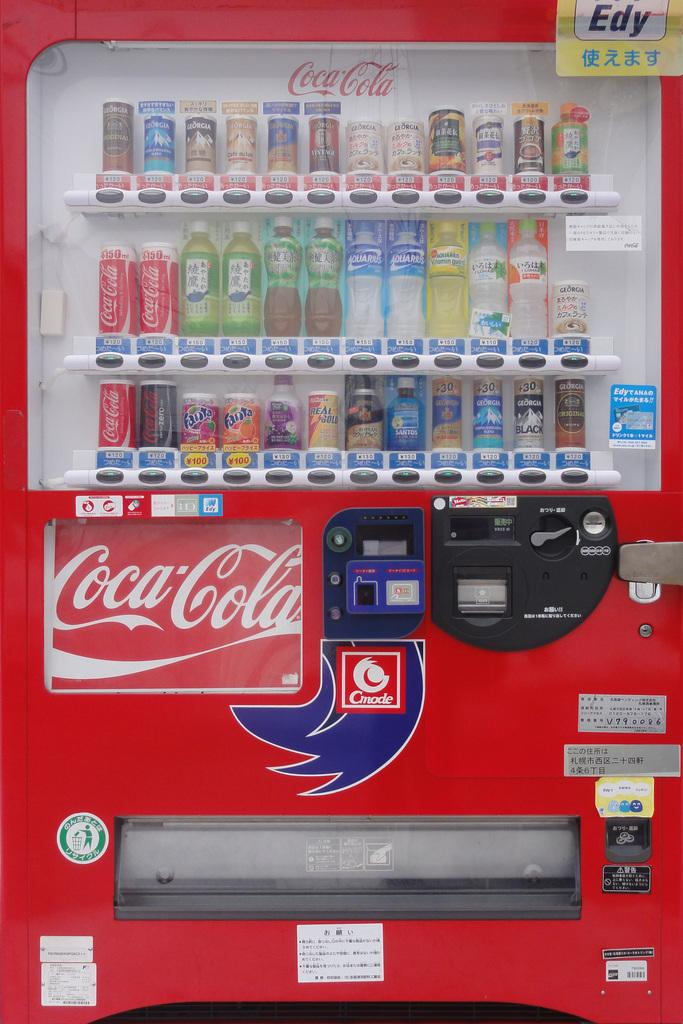<image>
Relay a brief, clear account of the picture shown. A vending machine with Coca Cola products like Fanta 